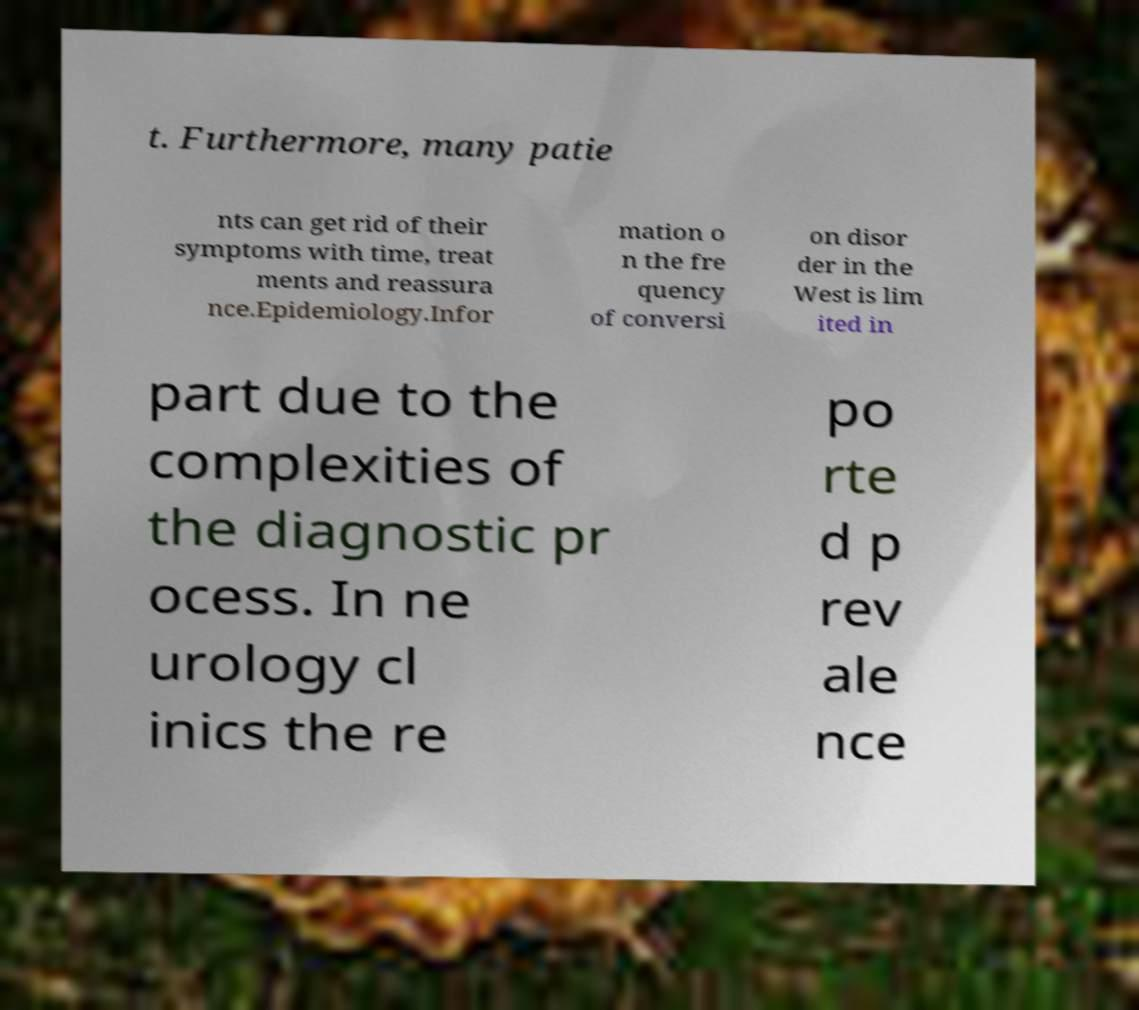What messages or text are displayed in this image? I need them in a readable, typed format. t. Furthermore, many patie nts can get rid of their symptoms with time, treat ments and reassura nce.Epidemiology.Infor mation o n the fre quency of conversi on disor der in the West is lim ited in part due to the complexities of the diagnostic pr ocess. In ne urology cl inics the re po rte d p rev ale nce 